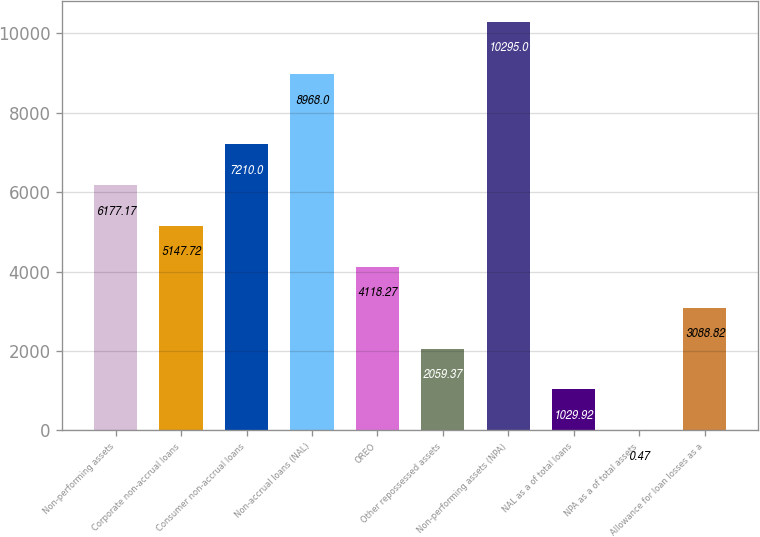Convert chart to OTSL. <chart><loc_0><loc_0><loc_500><loc_500><bar_chart><fcel>Non-performing assets<fcel>Corporate non-accrual loans<fcel>Consumer non-accrual loans<fcel>Non-accrual loans (NAL)<fcel>OREO<fcel>Other repossessed assets<fcel>Non-performing assets (NPA)<fcel>NAL as a of total loans<fcel>NPA as a of total assets<fcel>Allowance for loan losses as a<nl><fcel>6177.17<fcel>5147.72<fcel>7210<fcel>8968<fcel>4118.27<fcel>2059.37<fcel>10295<fcel>1029.92<fcel>0.47<fcel>3088.82<nl></chart> 